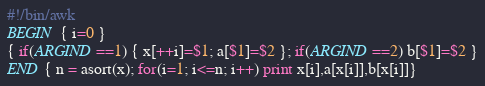Convert code to text. <code><loc_0><loc_0><loc_500><loc_500><_Awk_>#!/bin/awk
BEGIN { i=0 }
{ if(ARGIND==1) { x[++i]=$1; a[$1]=$2 }; if(ARGIND==2) b[$1]=$2 }
END { n = asort(x); for(i=1; i<=n; i++) print x[i],a[x[i]],b[x[i]]}
</code> 